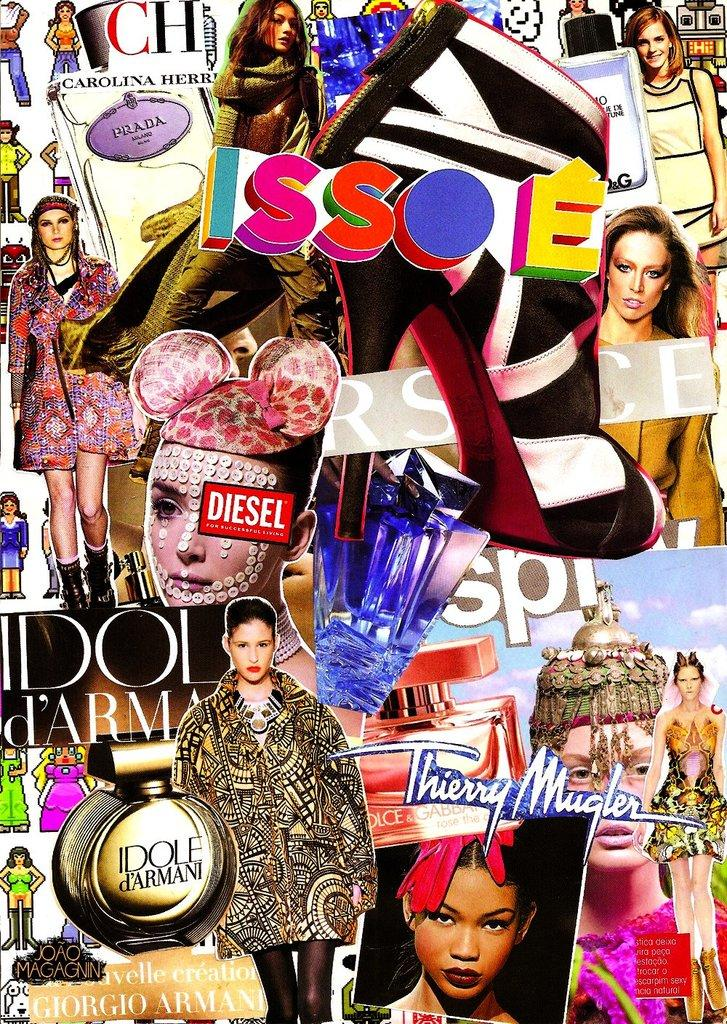<image>
Describe the image concisely. A collage from magazine cutouts including the word "Diesel." 